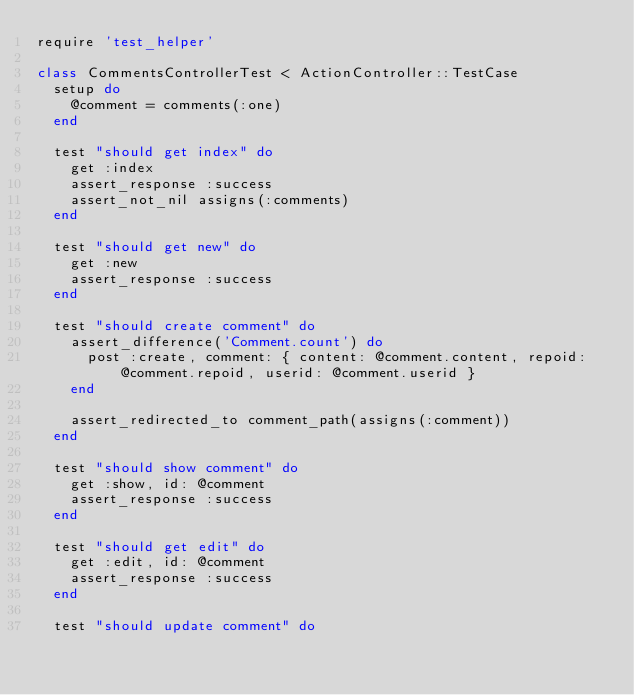Convert code to text. <code><loc_0><loc_0><loc_500><loc_500><_Ruby_>require 'test_helper'

class CommentsControllerTest < ActionController::TestCase
  setup do
    @comment = comments(:one)
  end

  test "should get index" do
    get :index
    assert_response :success
    assert_not_nil assigns(:comments)
  end

  test "should get new" do
    get :new
    assert_response :success
  end

  test "should create comment" do
    assert_difference('Comment.count') do
      post :create, comment: { content: @comment.content, repoid: @comment.repoid, userid: @comment.userid }
    end

    assert_redirected_to comment_path(assigns(:comment))
  end

  test "should show comment" do
    get :show, id: @comment
    assert_response :success
  end

  test "should get edit" do
    get :edit, id: @comment
    assert_response :success
  end

  test "should update comment" do</code> 